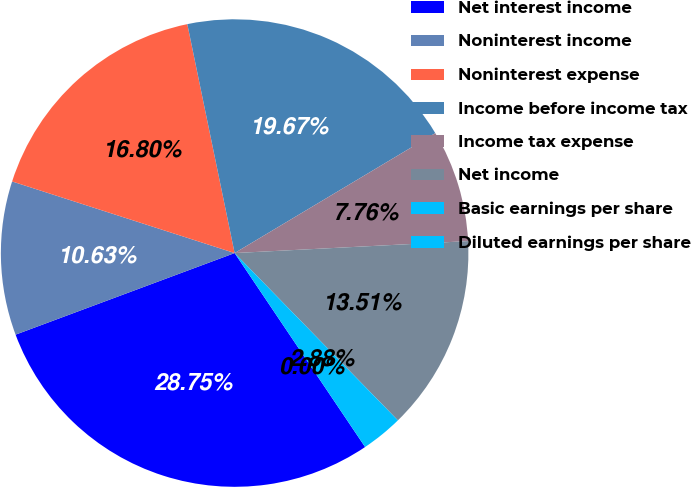<chart> <loc_0><loc_0><loc_500><loc_500><pie_chart><fcel>Net interest income<fcel>Noninterest income<fcel>Noninterest expense<fcel>Income before income tax<fcel>Income tax expense<fcel>Net income<fcel>Basic earnings per share<fcel>Diluted earnings per share<nl><fcel>28.75%<fcel>10.63%<fcel>16.8%<fcel>19.67%<fcel>7.76%<fcel>13.51%<fcel>2.88%<fcel>0.0%<nl></chart> 